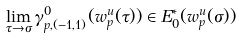Convert formula to latex. <formula><loc_0><loc_0><loc_500><loc_500>\lim _ { \tau \to \sigma } \gamma ^ { 0 } _ { p , ( - 1 , 1 ) } ( w ^ { u } _ { p } ( \tau ) ) \in E _ { 0 } ^ { * } ( w ^ { u } _ { p } ( \sigma ) )</formula> 